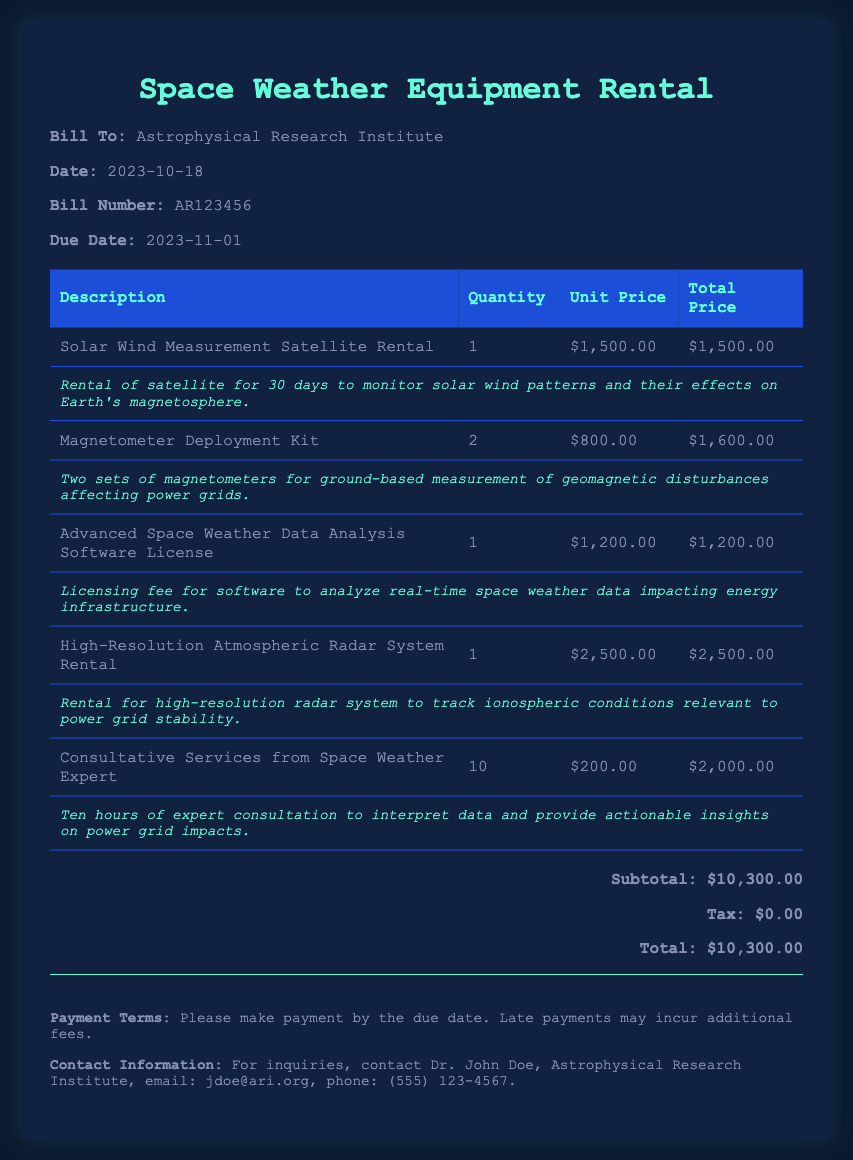What is the bill number? The bill number is listed in the document under "Bill Number."
Answer: AR123456 What is the due date for payment? The due date is provided in the document under "Due Date."
Answer: 2023-11-01 How many Solar Wind Measurement Satellites are being rented? The quantity of Solar Wind Measurement Satellites is found in the "Quantity" column of the relevant row.
Answer: 1 What is the total price for the Magnetometer Deployment Kit? The total price can be found in the "Total Price" column next to the corresponding item.
Answer: $1,600.00 What is the subtotal amount listed in the summary? The subtotal amount is presented in the summary section of the bill.
Answer: $10,300.00 What is included in the consultative services? The consultative services description indicates the type of service provided.
Answer: Expert consultation How many hours of consultation are provided? The number of hours is specified in the description of the consultative services.
Answer: 10 What is the email contact for inquiries? The contact email for inquiries is mentioned in the "Contact Information" section of the bill.
Answer: jdoe@ari.org What type of equipment is rented for tracking ionospheric conditions? The specific equipment rented for this purpose is listed in the description of one of the items.
Answer: High-Resolution Atmospheric Radar System 